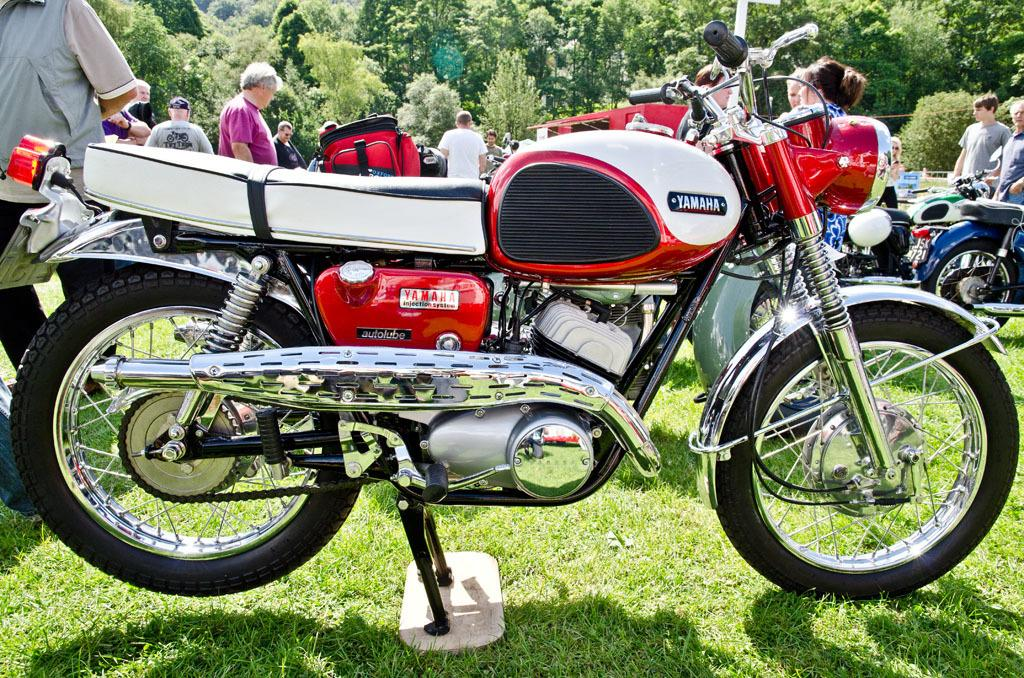What is the main subject of the image? The main subject of the image is a motorbike. What can be seen in the background of the image? There are people and trees in the background of the image. How many centimeters does the motorbike sink into the water in the image? There is no water present in the image, so the motorbike does not sink into the water. 